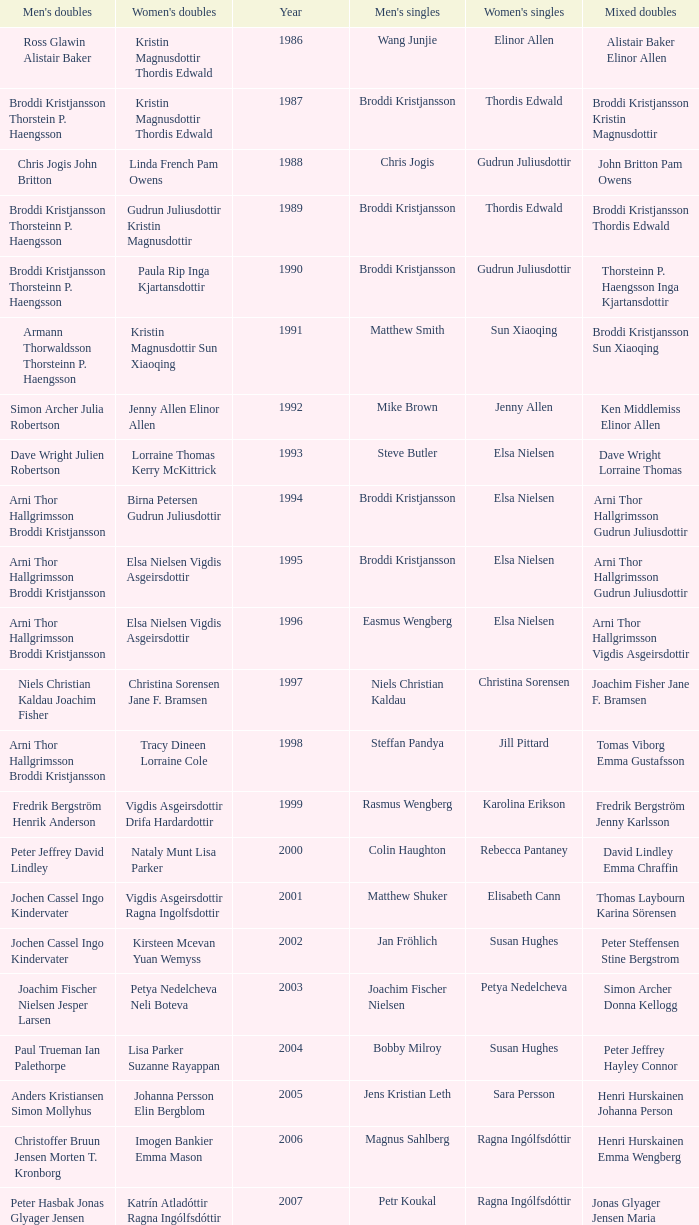In what mixed doubles did Niels Christian Kaldau play in men's singles? Joachim Fisher Jane F. Bramsen. 